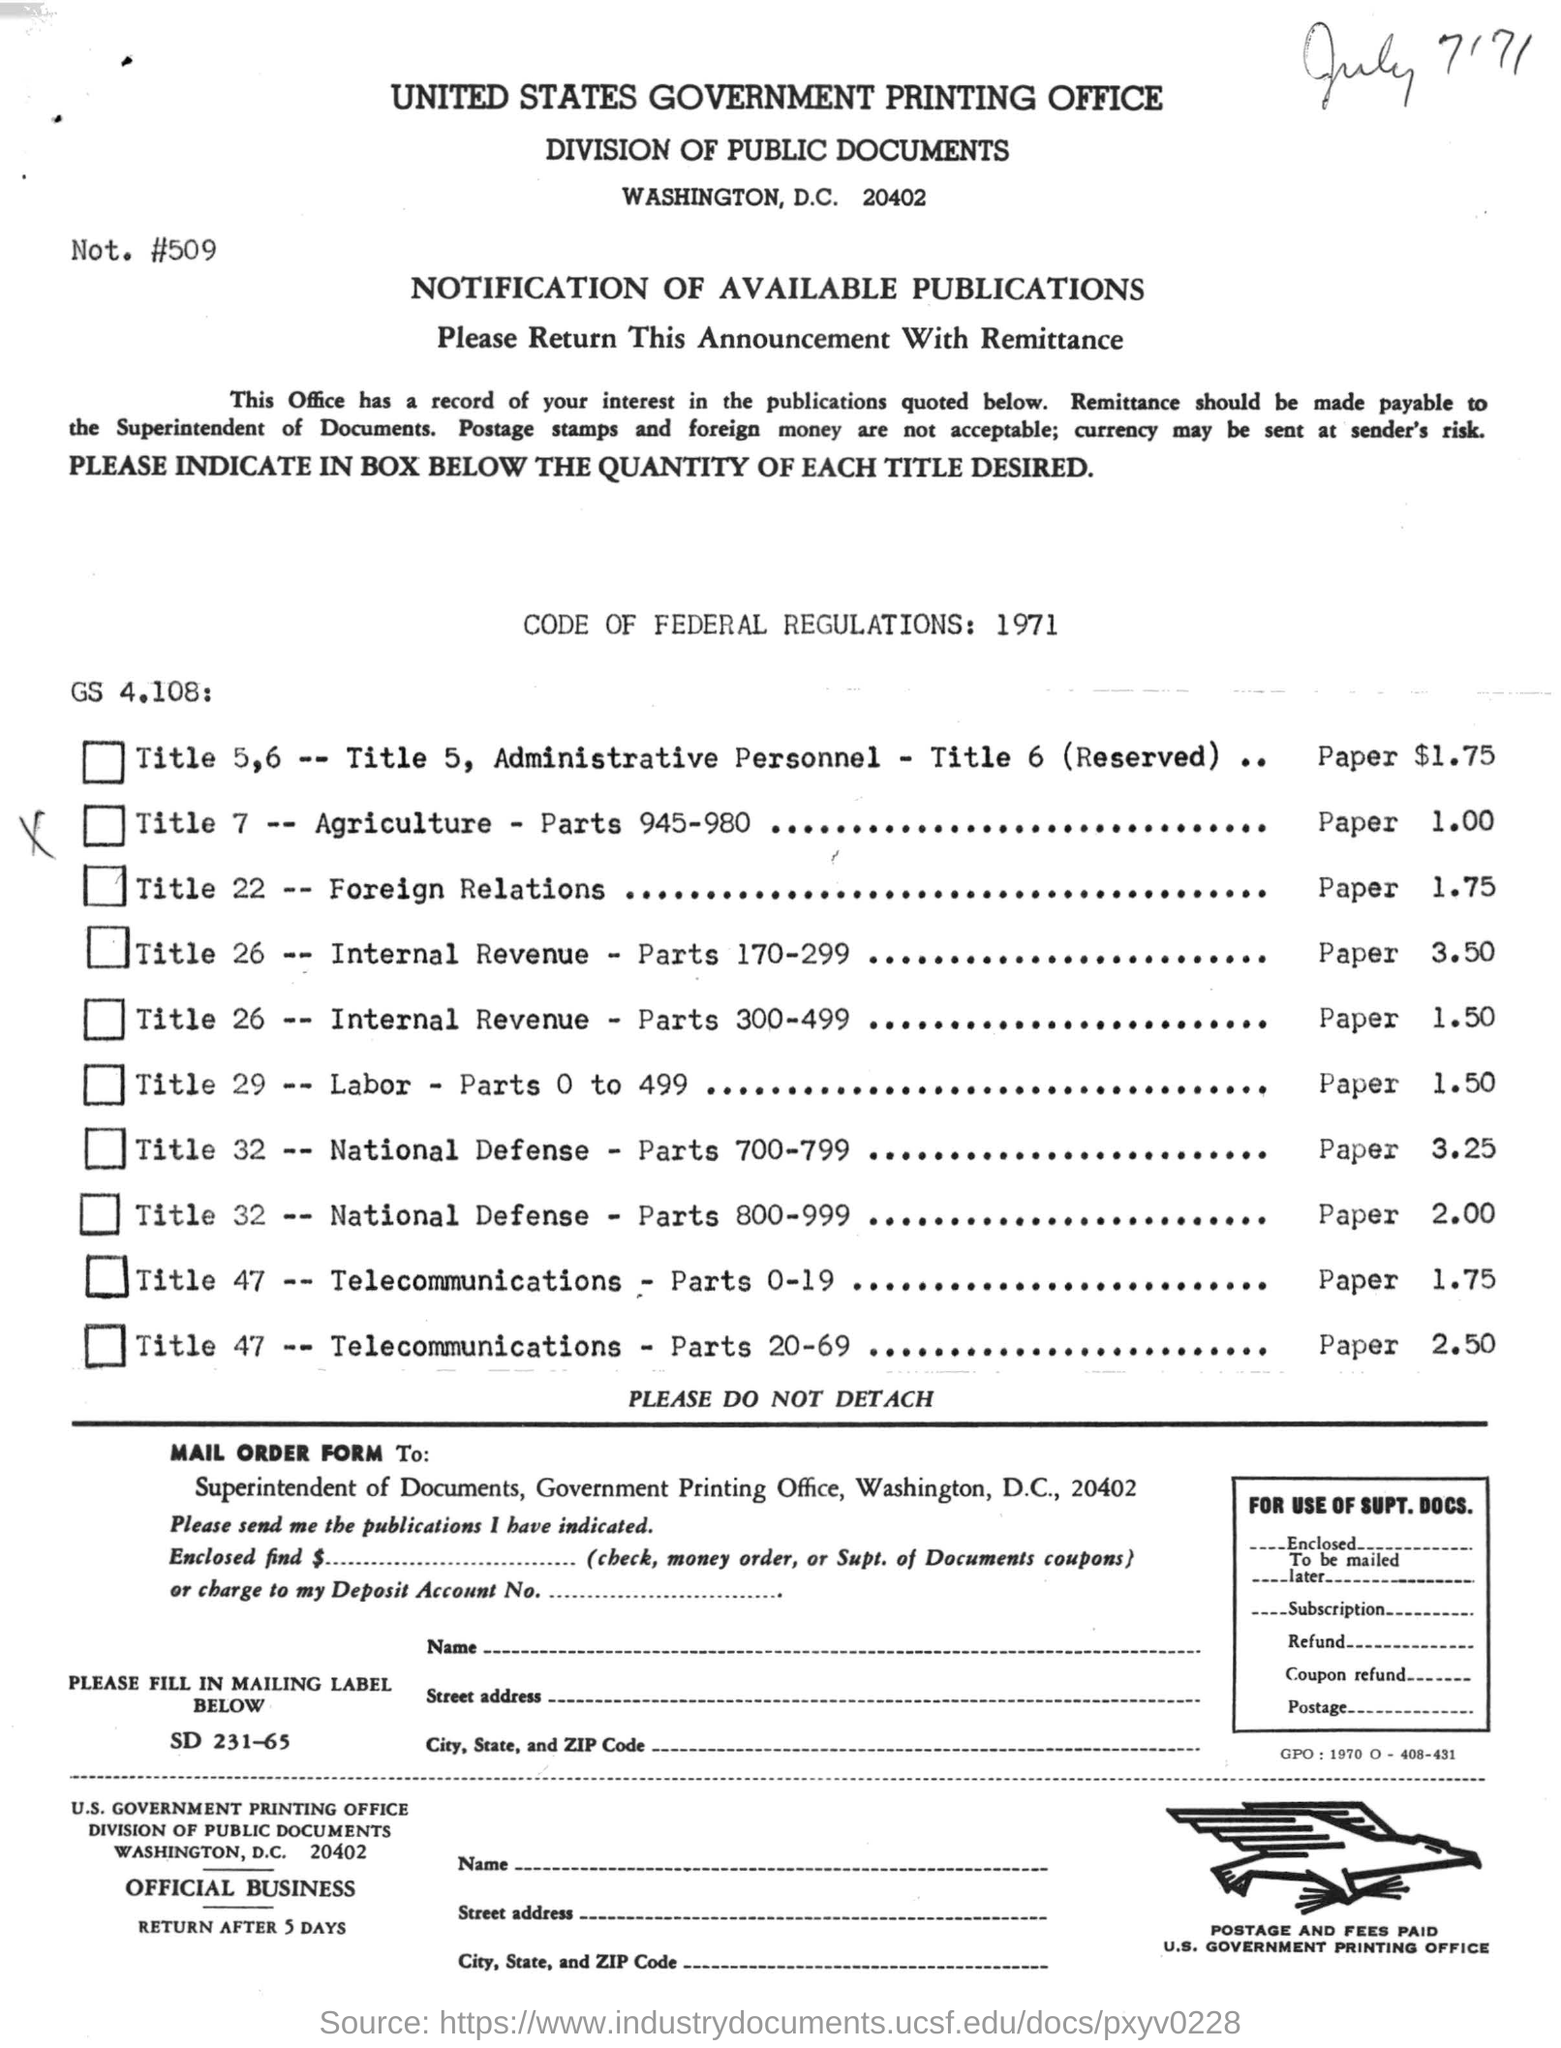Highlight a few significant elements in this photo. The United States Government Printing Office is the name of the printing office. The United States Code of Federal Regulations was written in the year 1971. 